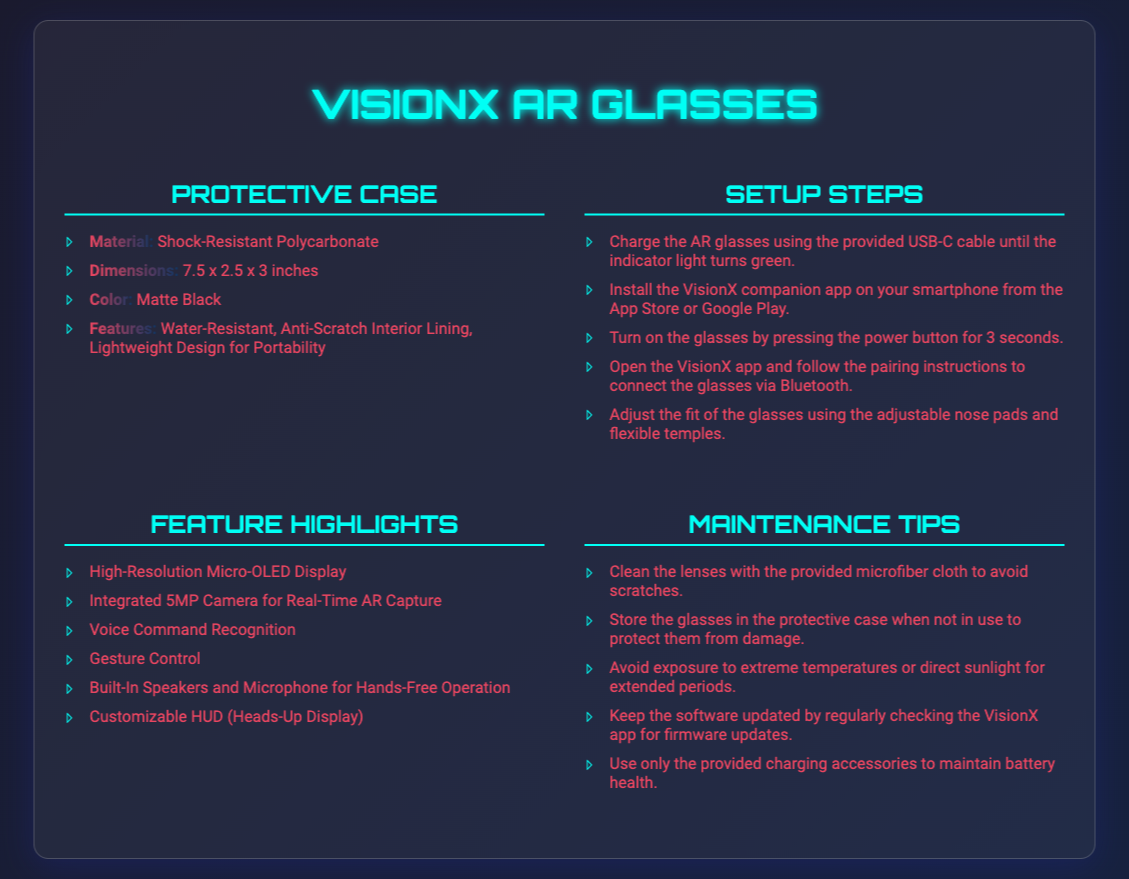What is the material of the protective case? The protective case is made of Shock-Resistant Polycarbonate.
Answer: Shock-Resistant Polycarbonate What are the dimensions of the protective case? The dimensions of the protective case are listed as 7.5 x 2.5 x 3 inches.
Answer: 7.5 x 2.5 x 3 inches How many steps are there in the setup process? The setup steps are outlined in a list, which contains five steps to complete the setup.
Answer: 5 What feature allows for hands-free operation? The glasses have Built-In Speakers and Microphone for hands-free operation.
Answer: Built-In Speakers and Microphone What is the suggested maintenance tip for cleaning the lenses? The advised maintenance tip is to clean the lenses with the provided microfiber cloth.
Answer: Microfiber cloth Which app needs to be installed for setup? The VisionX companion app is required for setup.
Answer: VisionX companion app What color is the protective case? The protective case is colored Matte Black.
Answer: Matte Black What component of the glasses is integrated for real-time AR capture? The AR glasses include an Integrated 5MP Camera for this function.
Answer: Integrated 5MP Camera What should be done to ensure the battery health is maintained? Using only the provided charging accessories is recommended to maintain battery health.
Answer: Provided charging accessories 